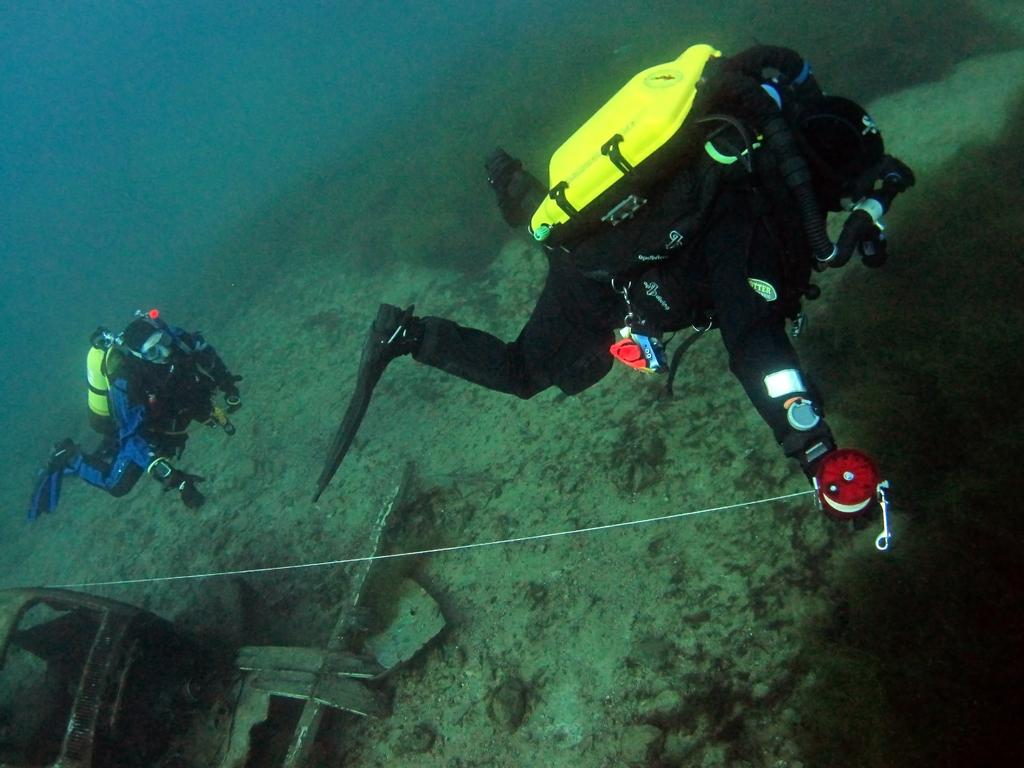What are the two people in the image doing? The two people in the image are swimming. What are the people wearing while swimming? The people are wearing swimming suits. What additional equipment do the people have while swimming? The people have oxygen cylinders on their backs. Can you describe the unspecified object in the image? Unfortunately, the facts provided do not give any details about the unspecified object in the image. What type of frame is surrounding the snake in the image? There is no snake present in the image, so there is no frame surrounding it. 